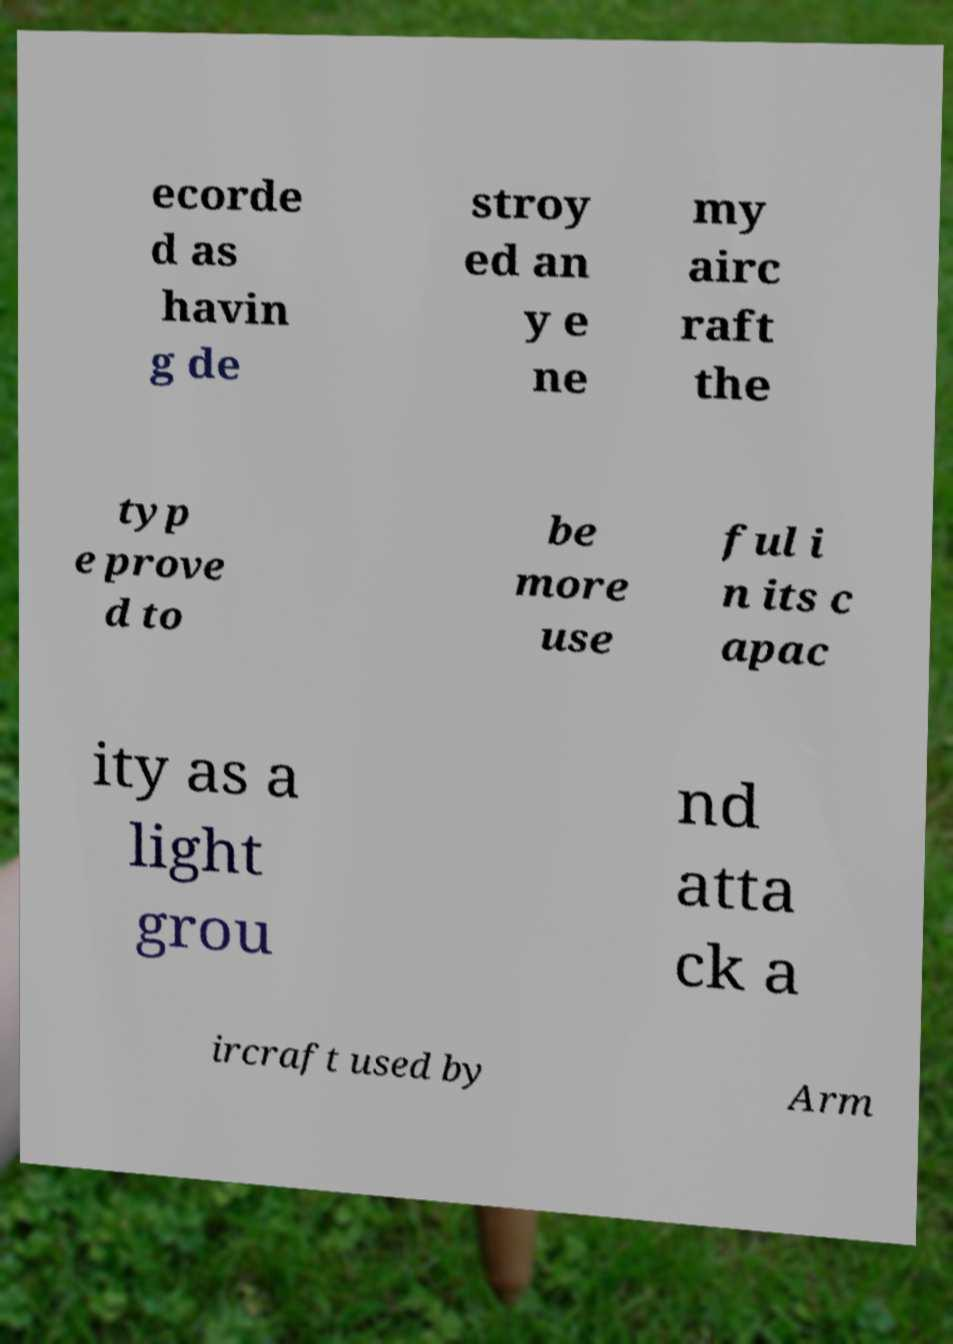Could you assist in decoding the text presented in this image and type it out clearly? ecorde d as havin g de stroy ed an y e ne my airc raft the typ e prove d to be more use ful i n its c apac ity as a light grou nd atta ck a ircraft used by Arm 